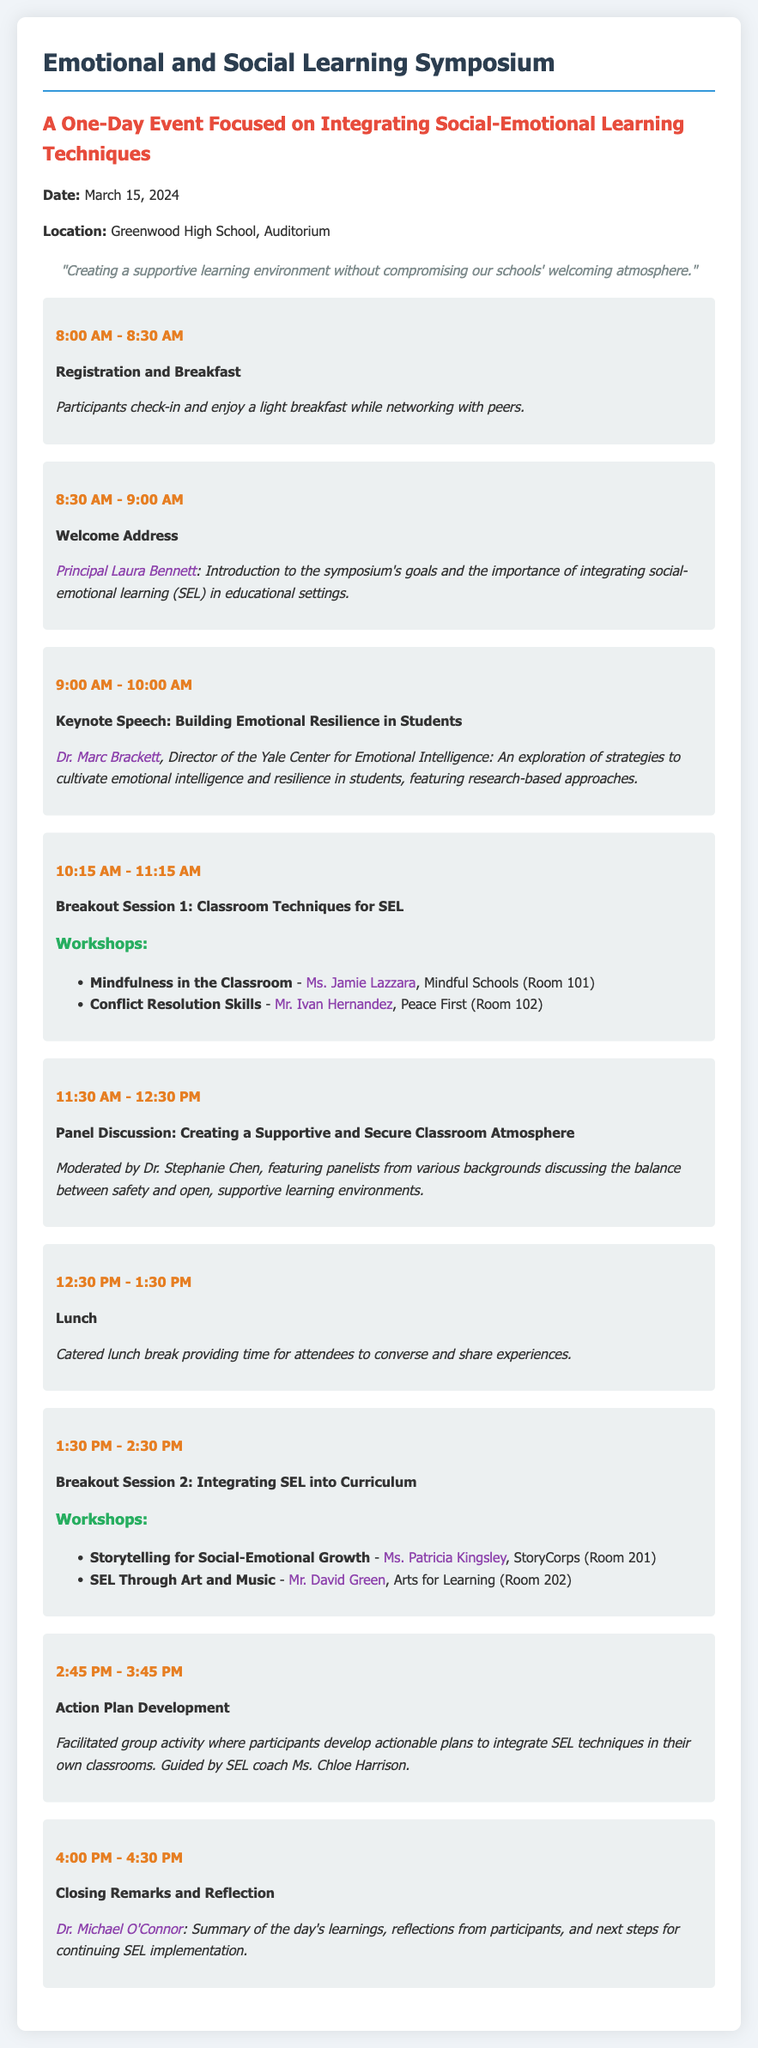What is the date of the symposium? The date of the symposium is clearly stated in the document as March 15, 2024.
Answer: March 15, 2024 Who will deliver the keynote speech? The document specifies that Dr. Marc Brackett will deliver the keynote speech.
Answer: Dr. Marc Brackett What is the main focus of the breakout sessions? The breakout sessions are primarily focused on social-emotional learning (SEL) techniques.
Answer: Social-Emotional Learning (SEL) techniques What is the total length of the lunch break? The document indicates that the lunch break lasts for one hour from 12:30 PM to 1:30 PM.
Answer: One hour Who moderates the panel discussion? The panel discussion is moderated by Dr. Stephanie Chen, as mentioned in the details.
Answer: Dr. Stephanie Chen What is the time for registration? The registration time is specified as 8:00 AM to 8:30 AM in the agenda.
Answer: 8:00 AM - 8:30 AM Which room is the "Mindfulness in the Classroom" workshop held in? The "Mindfulness in the Classroom" workshop is held in Room 101, as per the breakout session details.
Answer: Room 101 What will participants work on during the action plan development? During the action plan development, participants will focus on integrating SEL techniques in their classrooms.
Answer: Integrating SEL techniques in their classrooms 